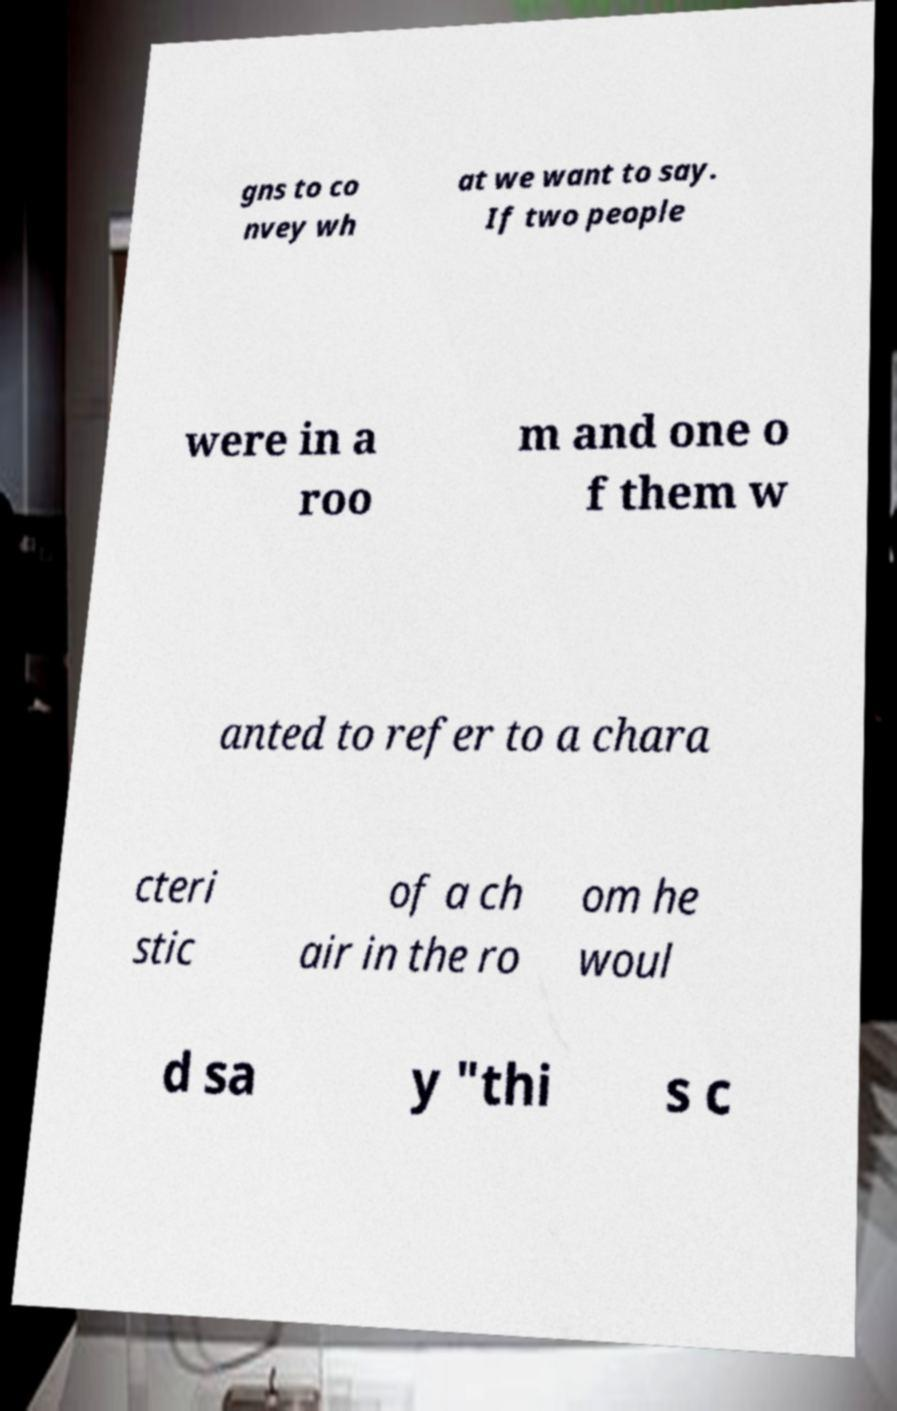Could you extract and type out the text from this image? gns to co nvey wh at we want to say. If two people were in a roo m and one o f them w anted to refer to a chara cteri stic of a ch air in the ro om he woul d sa y "thi s c 